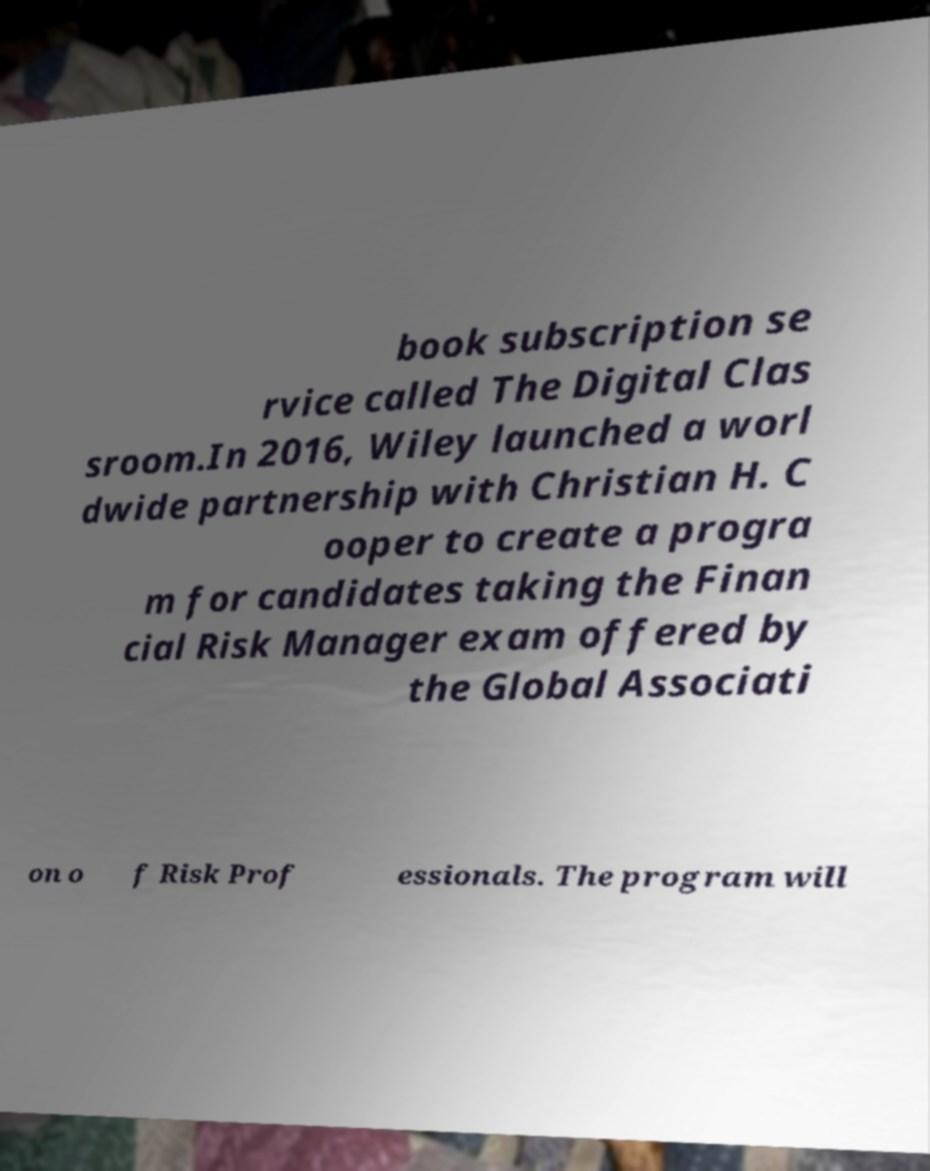Please identify and transcribe the text found in this image. book subscription se rvice called The Digital Clas sroom.In 2016, Wiley launched a worl dwide partnership with Christian H. C ooper to create a progra m for candidates taking the Finan cial Risk Manager exam offered by the Global Associati on o f Risk Prof essionals. The program will 